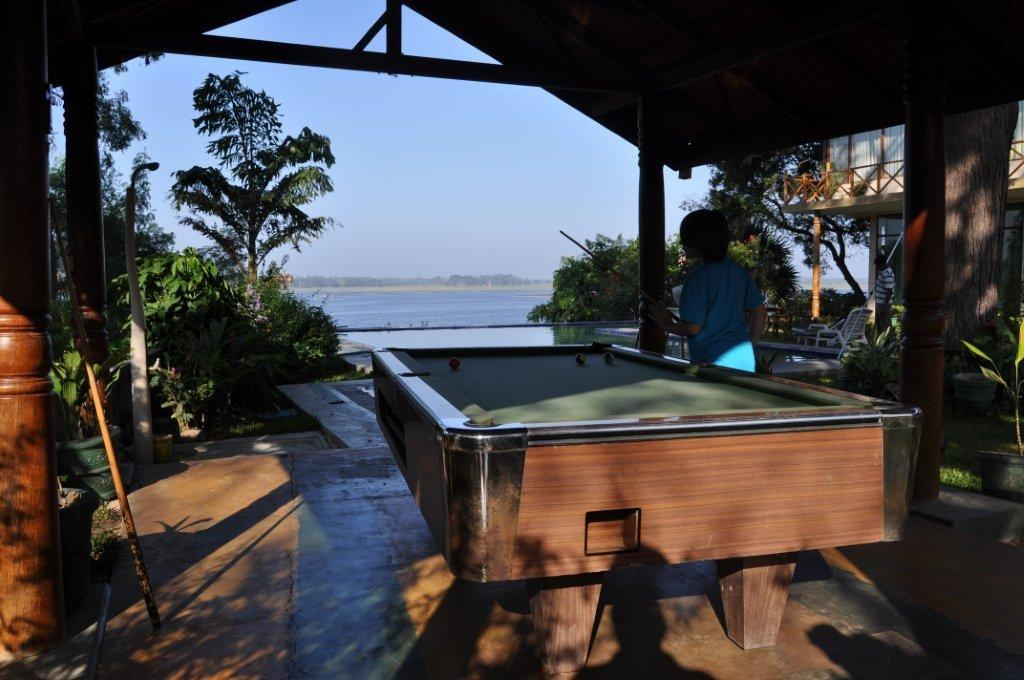What can be seen in the sky in the image? The sky is visible in the image, but no specific details are provided. What is the water element in the image? There is water in the image, but no further details are given. What type of vegetation is present in the image? There are trees in the image. Can you describe the human in the image? There is a human standing in the image, but no additional details are provided. What type of game or activity is featured in the image? There is a billiards board in the image, which suggests a game or activity involving balls and cues. Where is the volleyball net located in the image? There is no volleyball net in the image. 